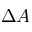Convert formula to latex. <formula><loc_0><loc_0><loc_500><loc_500>\Delta A</formula> 